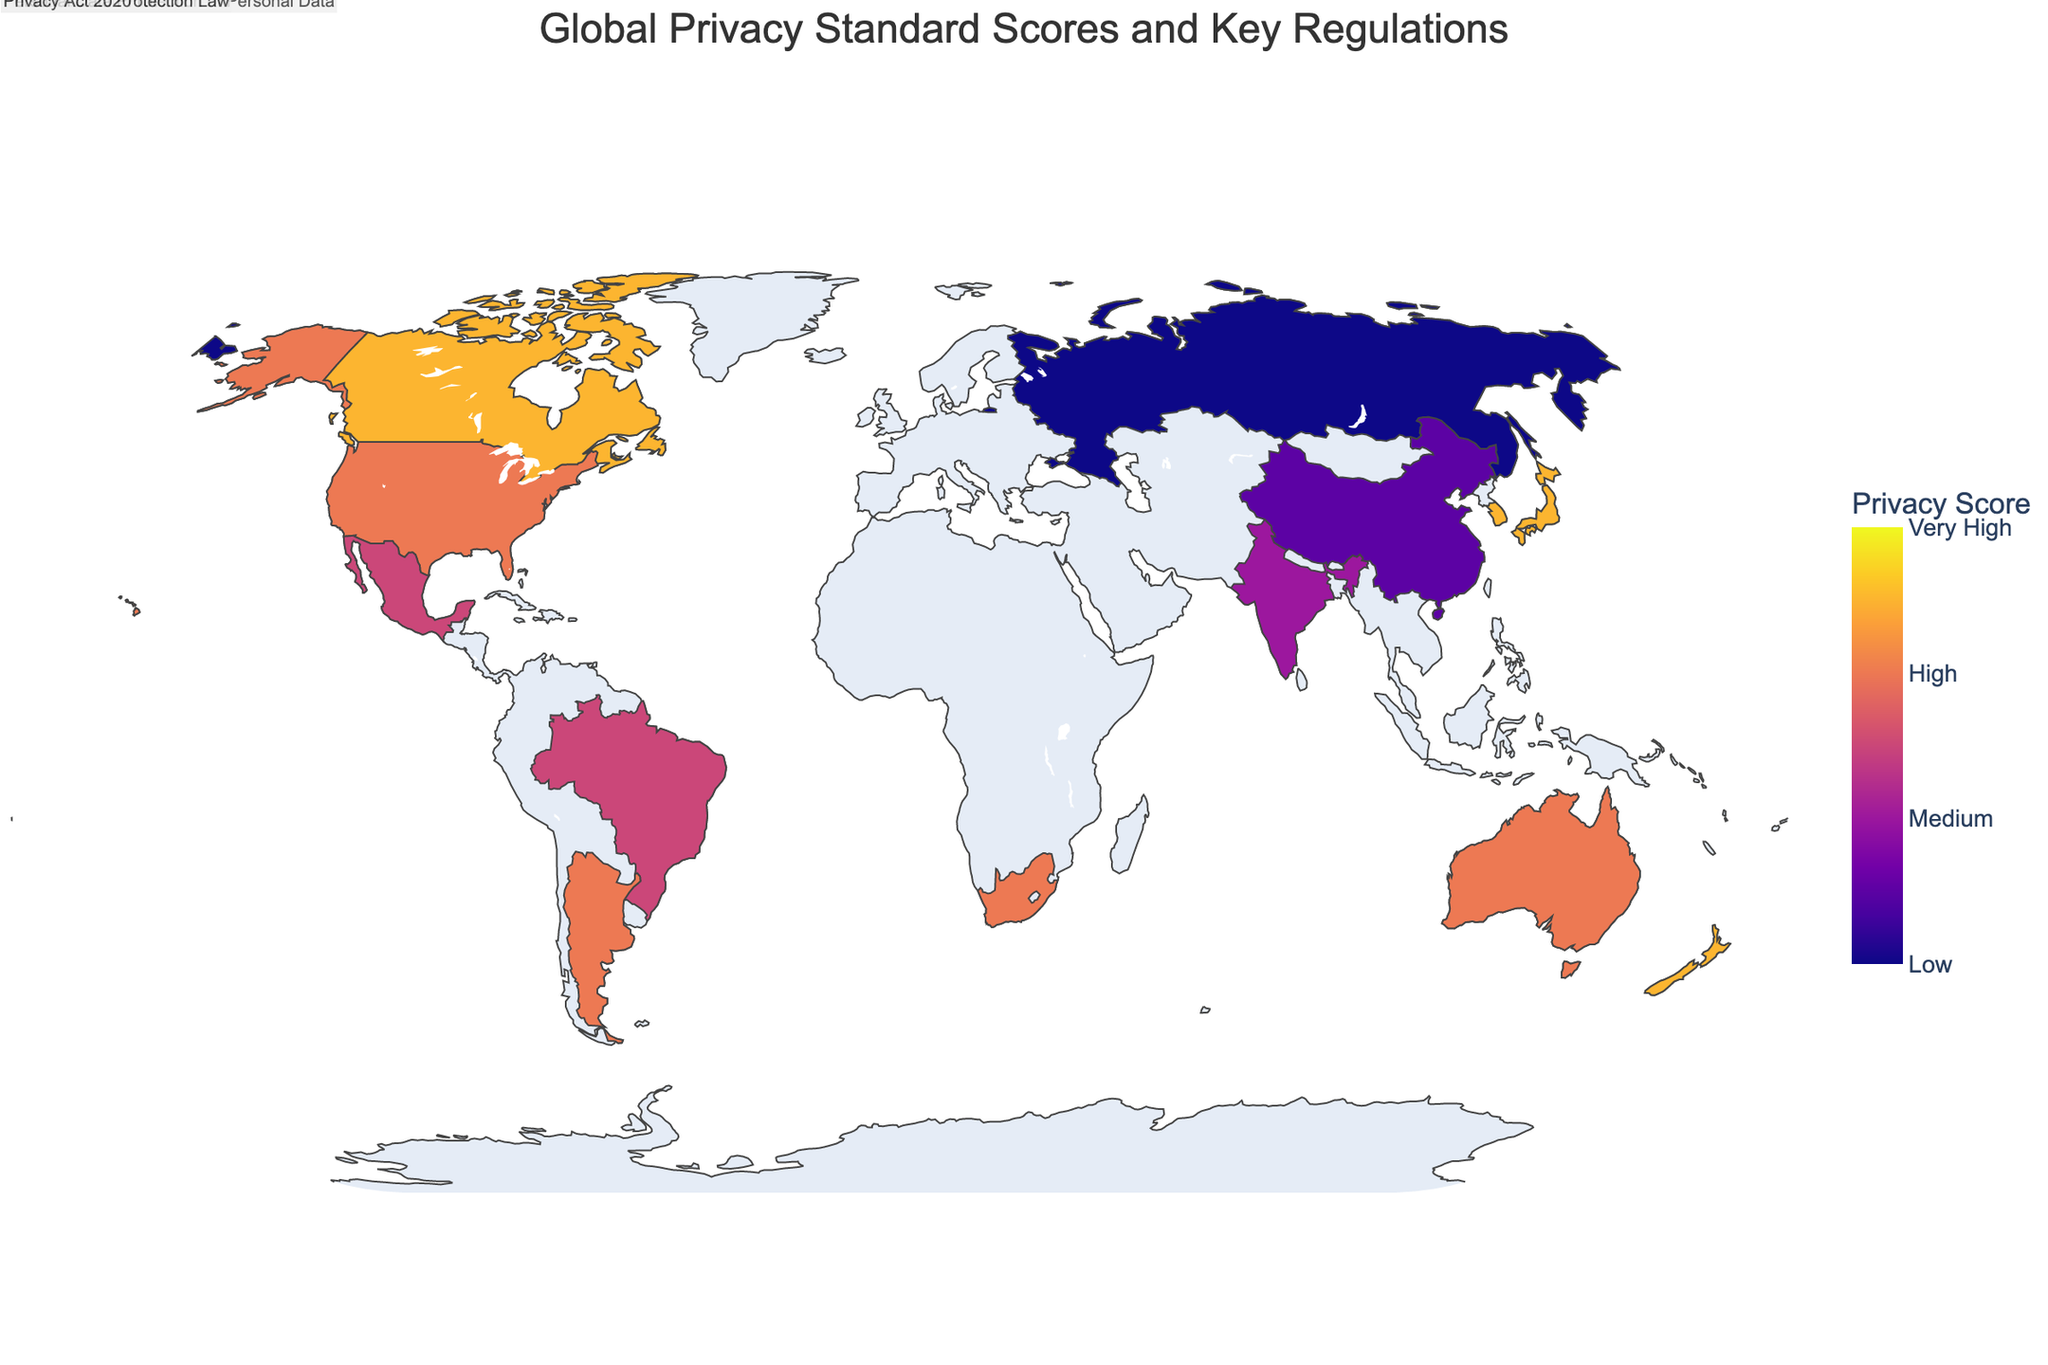what is the title of the figure? The title of the figure is usually placed at the top center above the map. In this case, it reads "Global Privacy Standard Scores and Key Regulations."
Answer: Global Privacy Standard Scores and Key Regulations what color represents the highest privacy standard score on the map? The color representing the highest privacy standard score is usually indicated by the color scale. Here, it is the darkest color on the Plasma color scale used, which is a deep purple.
Answer: Deep purple How many countries have a privacy standard score of 8? To find the number of countries with a privacy standard score of 8, we look for countries listed with this value and count them. The figure shows Canada, Japan, South Korea, and New Zealand, making a total of four.
Answer: 4 Which country has the lowest privacy standard score and what is its key regulation? The country with the lowest score can be found by identifying the country with the smallest number in the privacy standard score on the map. Here, Russia has the lowest score of 3, with the key regulation being the Data Protection Act.
Answer: Russia, Data Protection Act What is the average privacy standard score of all the countries shown? To calculate the average, sum all the privacy standard scores and divide by the number of countries: (7+9+8+7+8+6+5+4+7+3+6+8+6+7+8)/15 = 7
Answer: 7 Which country in South America has a privacy standard score of 7 and what is its key regulation? We identify the country in the South American continent on the map with a privacy standard score of 7. Argentina meets this criterion with its Personal Data Protection Law.
Answer: Argentina, Personal Data Protection Law Compare the privacy standard scores of the United States and the European Union. Which one is higher? To compare, we look at the scores listed for each region: United States has a score of 7 and the European Union has a score of 9. Therefore, the European Union has a higher score.
Answer: European Union Which region appears to have the most stringent data protection laws based on the privacy standard score presented? By inspecting the regions with the highest scores, the European Union, shown with a score of 9, appears to have the most stringent data protection laws.
Answer: European Union Are there any countries that share the same privacy standard score and key regulation? We look for any repeated entries in the data with a shared score and regulation. No countries have both the same privacy standard score and identical key regulation.
Answer: No 